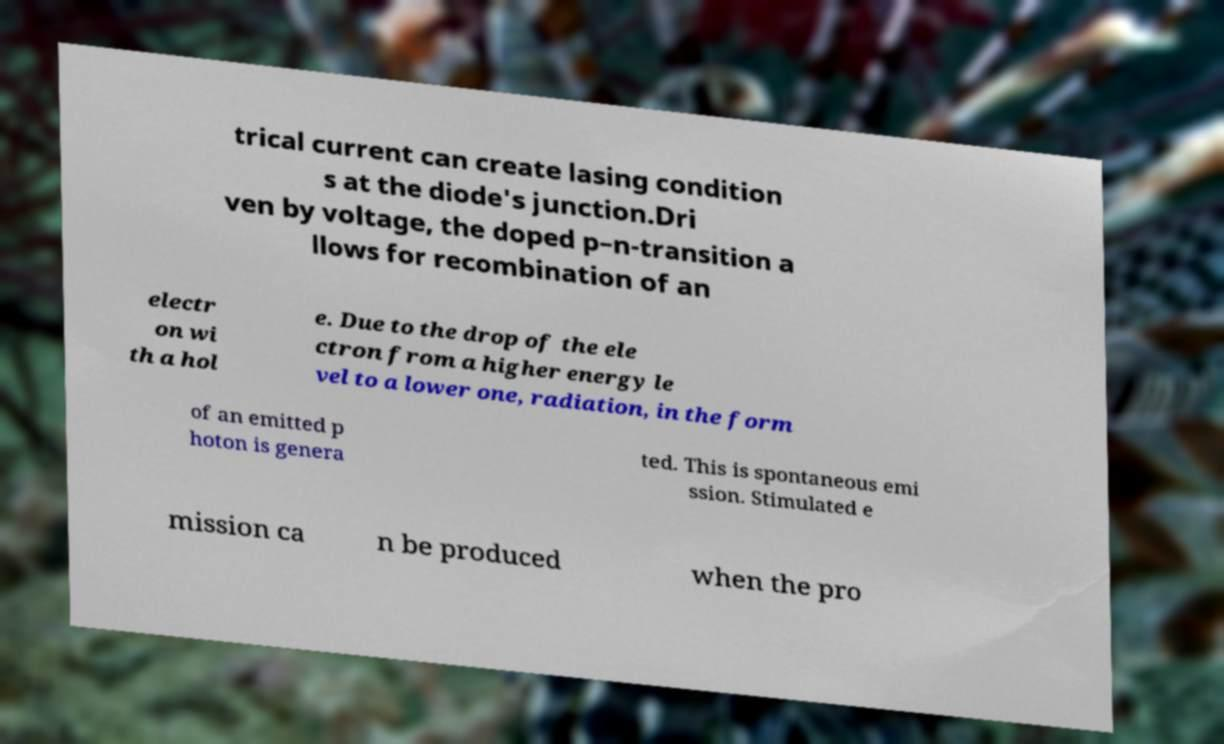Could you extract and type out the text from this image? trical current can create lasing condition s at the diode's junction.Dri ven by voltage, the doped p–n-transition a llows for recombination of an electr on wi th a hol e. Due to the drop of the ele ctron from a higher energy le vel to a lower one, radiation, in the form of an emitted p hoton is genera ted. This is spontaneous emi ssion. Stimulated e mission ca n be produced when the pro 